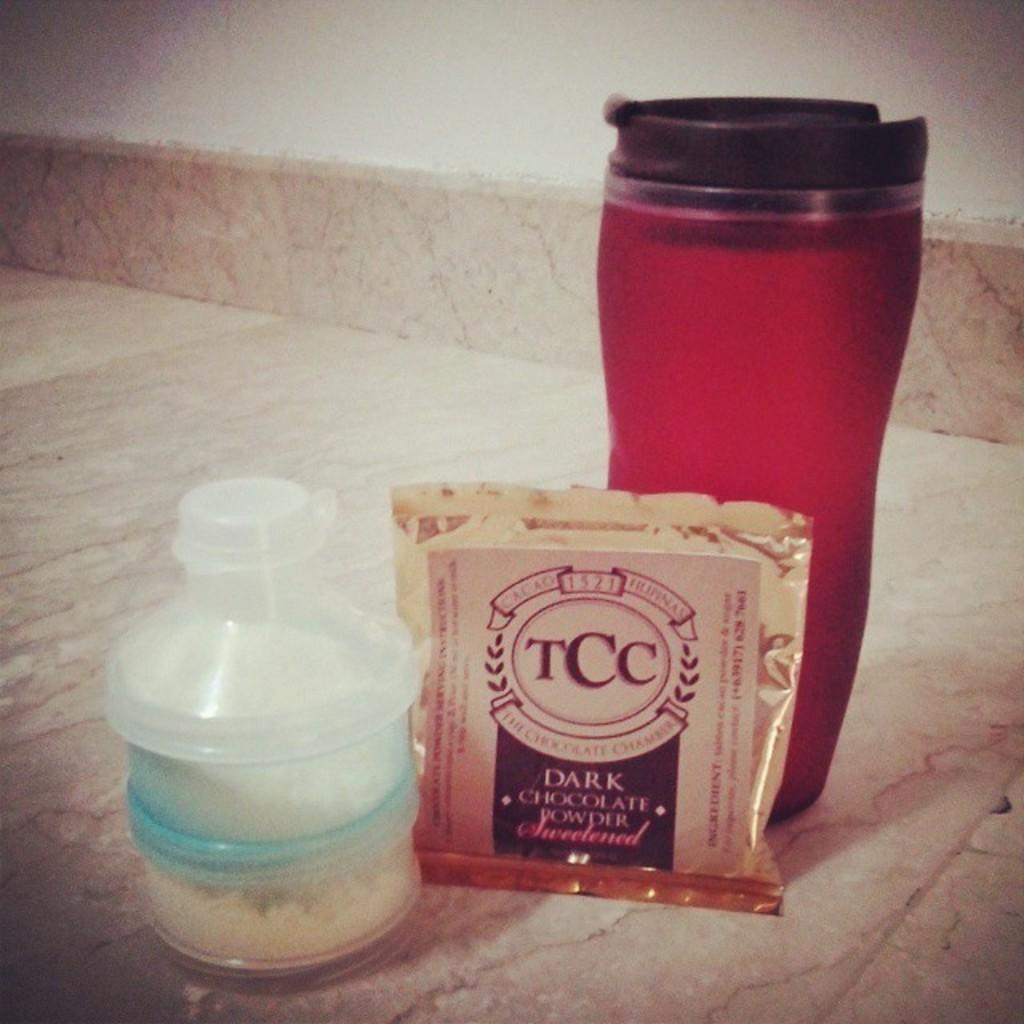<image>
Summarize the visual content of the image. Red cup next to a square chocolate that says TCC on it. 